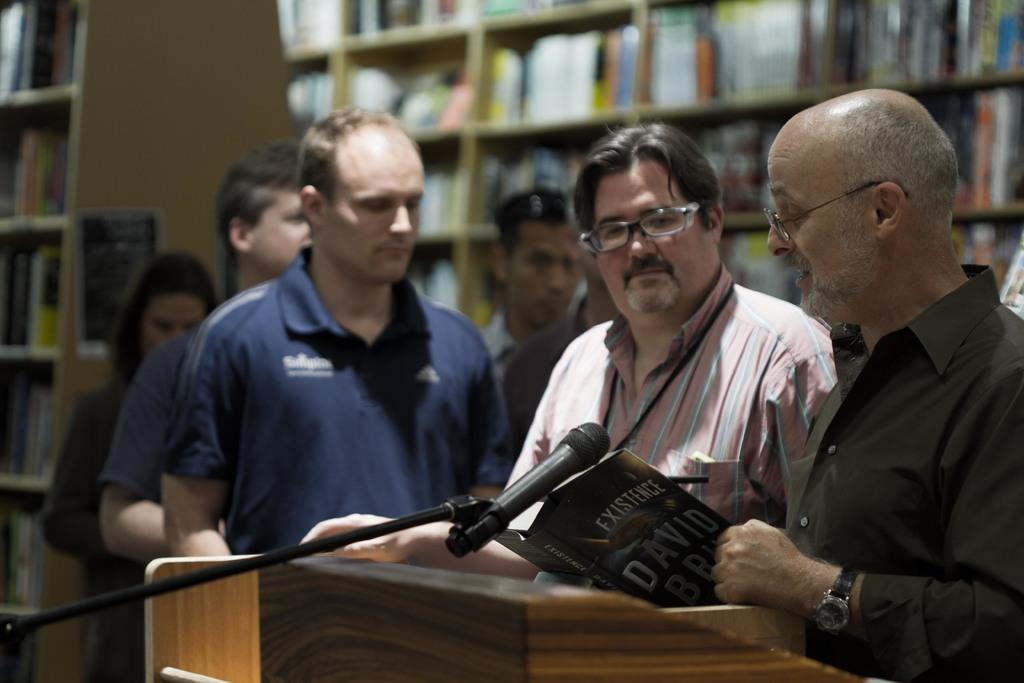<image>
Offer a succinct explanation of the picture presented. Men waiting in line for book signing of Existence. 